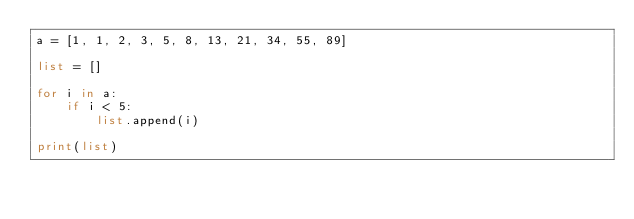<code> <loc_0><loc_0><loc_500><loc_500><_Python_>a = [1, 1, 2, 3, 5, 8, 13, 21, 34, 55, 89]

list = []

for i in a:
    if i < 5:
        list.append(i)

print(list)

</code> 